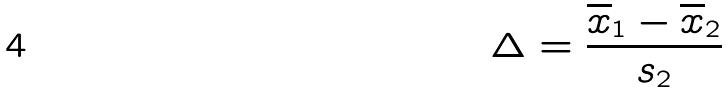<formula> <loc_0><loc_0><loc_500><loc_500>\Delta = \frac { \overline { x } _ { 1 } - \overline { x } _ { 2 } } { s _ { 2 } }</formula> 